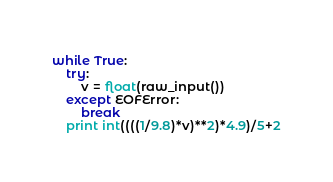Convert code to text. <code><loc_0><loc_0><loc_500><loc_500><_Python_>while True:
    try:
        v = float(raw_input())
    except EOFError:
        break
    print int((((1/9.8)*v)**2)*4.9)/5+2</code> 